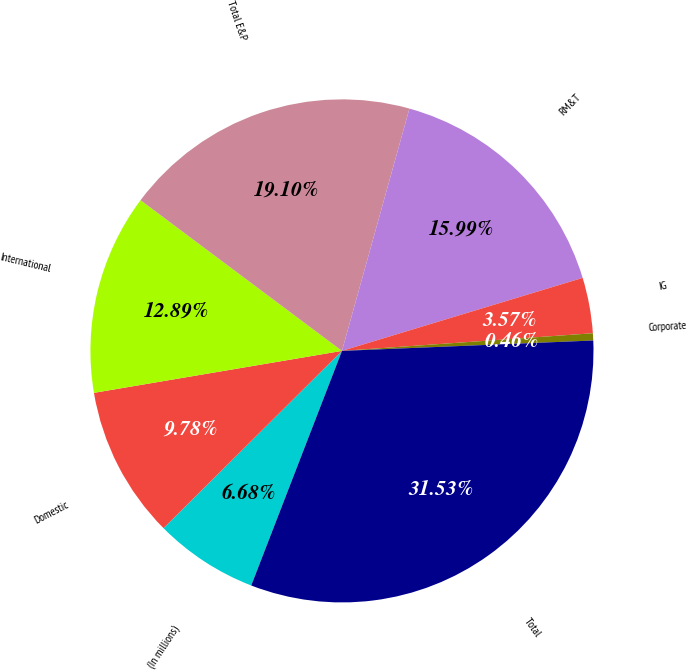Convert chart. <chart><loc_0><loc_0><loc_500><loc_500><pie_chart><fcel>(In millions)<fcel>Domestic<fcel>International<fcel>Total E&P<fcel>RM&T<fcel>IG<fcel>Corporate<fcel>Total<nl><fcel>6.68%<fcel>9.78%<fcel>12.89%<fcel>19.1%<fcel>15.99%<fcel>3.57%<fcel>0.46%<fcel>31.53%<nl></chart> 